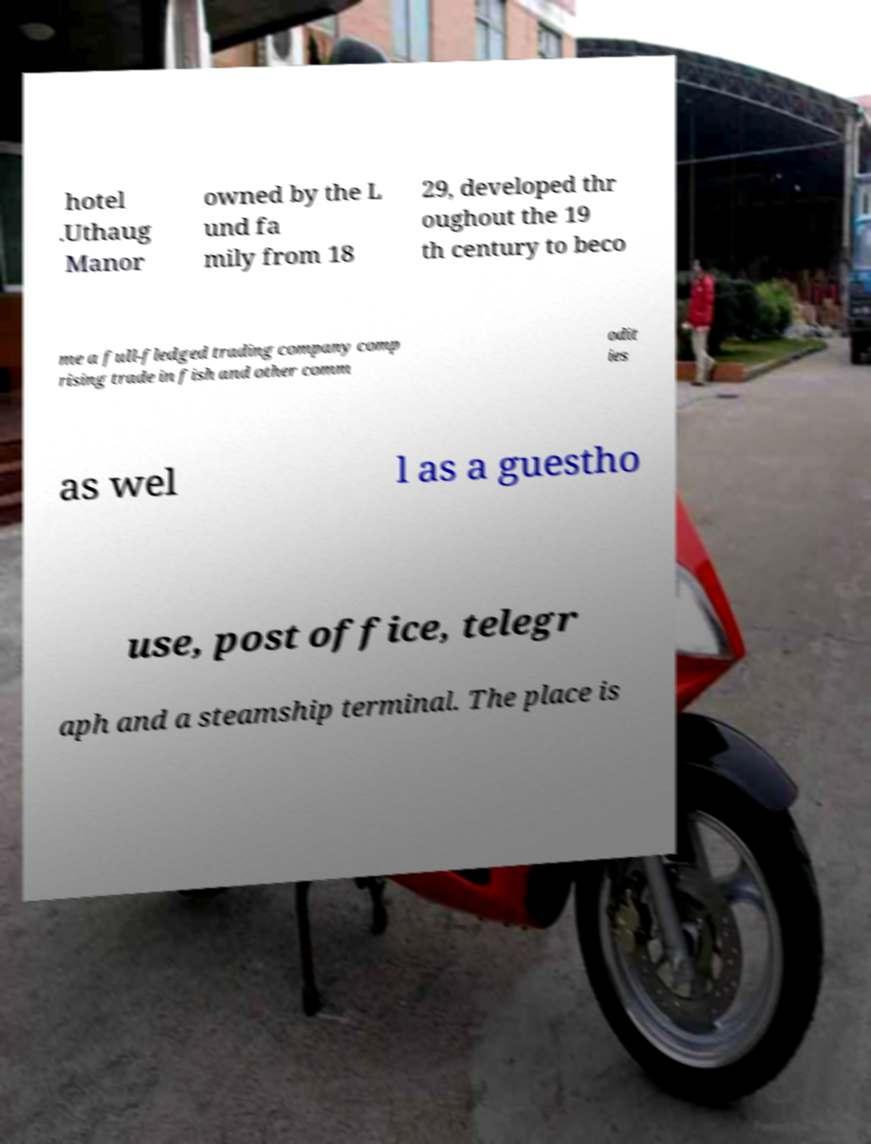What messages or text are displayed in this image? I need them in a readable, typed format. hotel .Uthaug Manor owned by the L und fa mily from 18 29, developed thr oughout the 19 th century to beco me a full-fledged trading company comp rising trade in fish and other comm odit ies as wel l as a guestho use, post office, telegr aph and a steamship terminal. The place is 